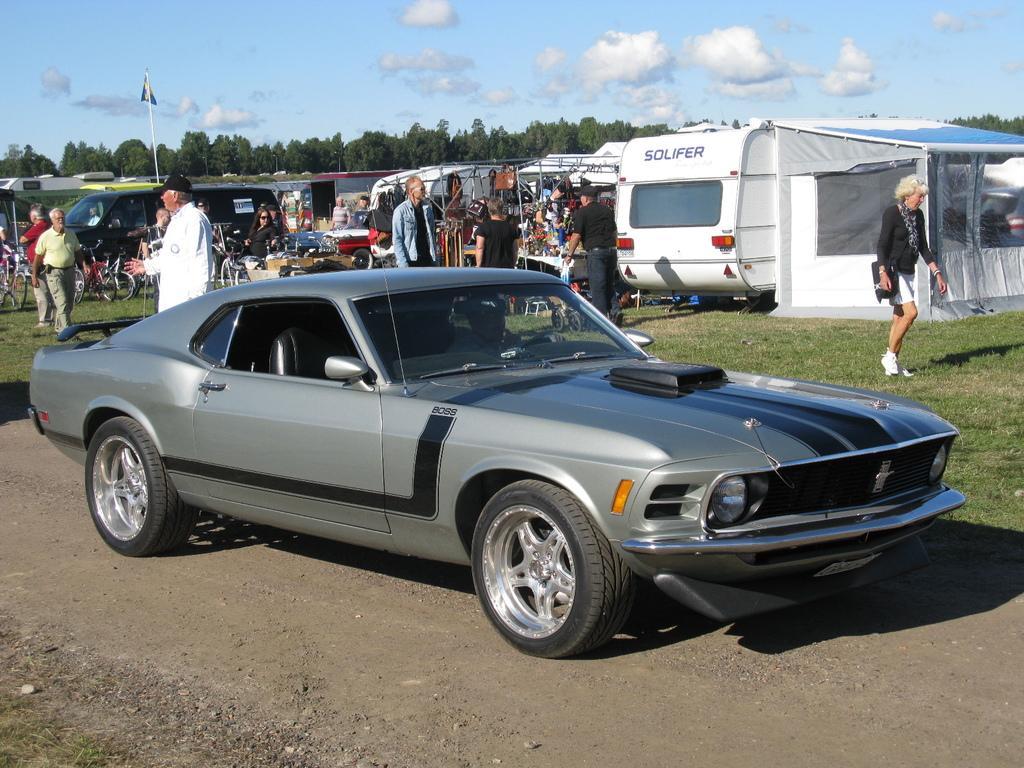Can you describe this image briefly? In this picture there are people and we can see vehicles, grass, tent and few objects. In the background of the image we can see flag on pole, trees and sky with clouds. 